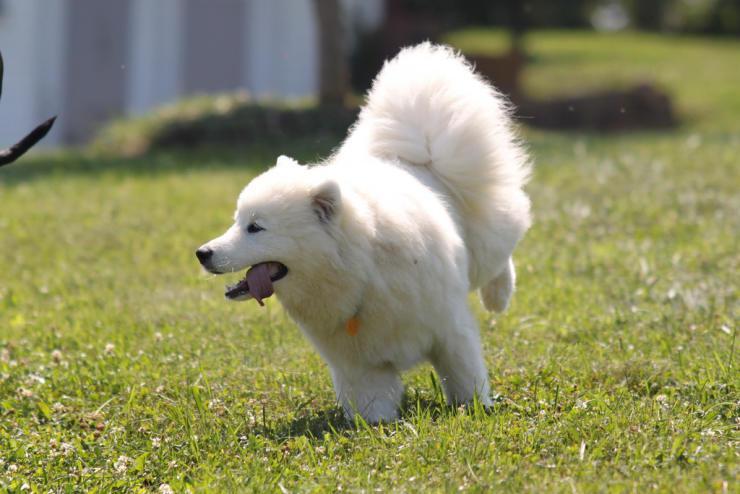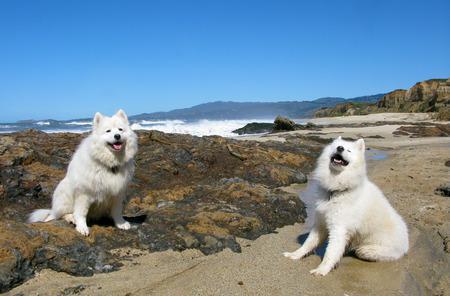The first image is the image on the left, the second image is the image on the right. For the images shown, is this caption "The right image includes at least twice the number of dogs as the left image." true? Answer yes or no. Yes. The first image is the image on the left, the second image is the image on the right. For the images displayed, is the sentence "A white dog is standing on the rocky shore of a beach." factually correct? Answer yes or no. No. 